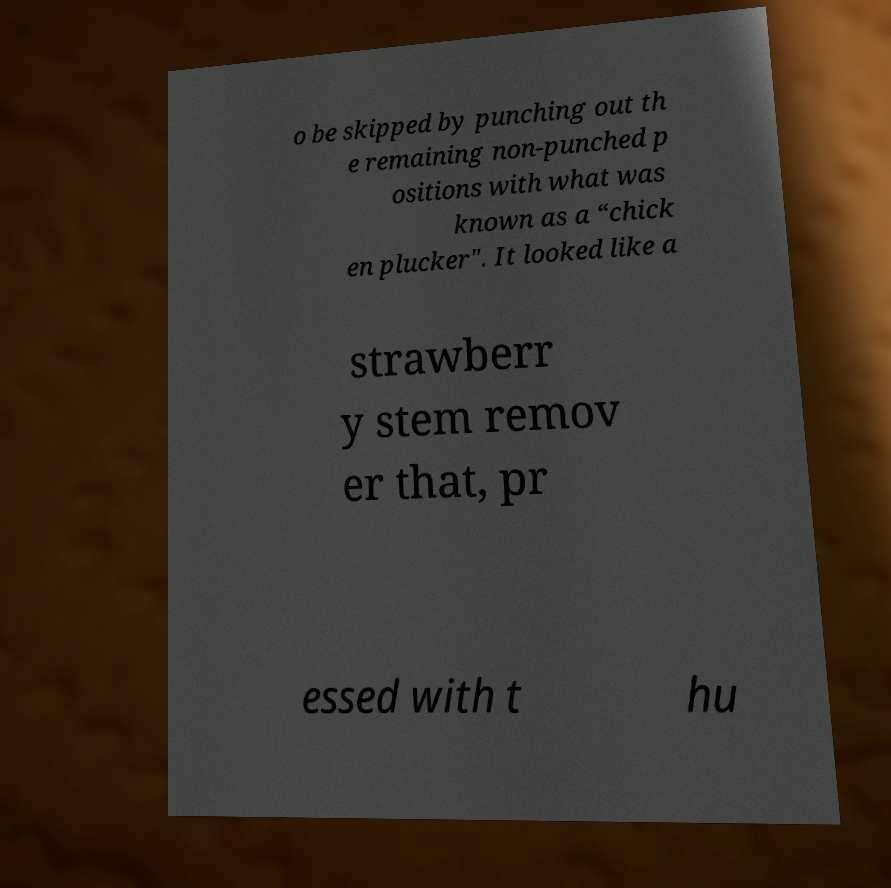What messages or text are displayed in this image? I need them in a readable, typed format. o be skipped by punching out th e remaining non-punched p ositions with what was known as a “chick en plucker". It looked like a strawberr y stem remov er that, pr essed with t hu 